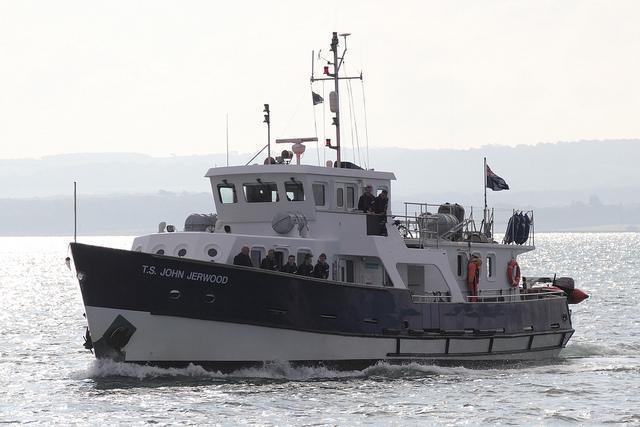How many letters are in the ship's name?
Give a very brief answer. 13. How many horses are in the picture?
Give a very brief answer. 0. 